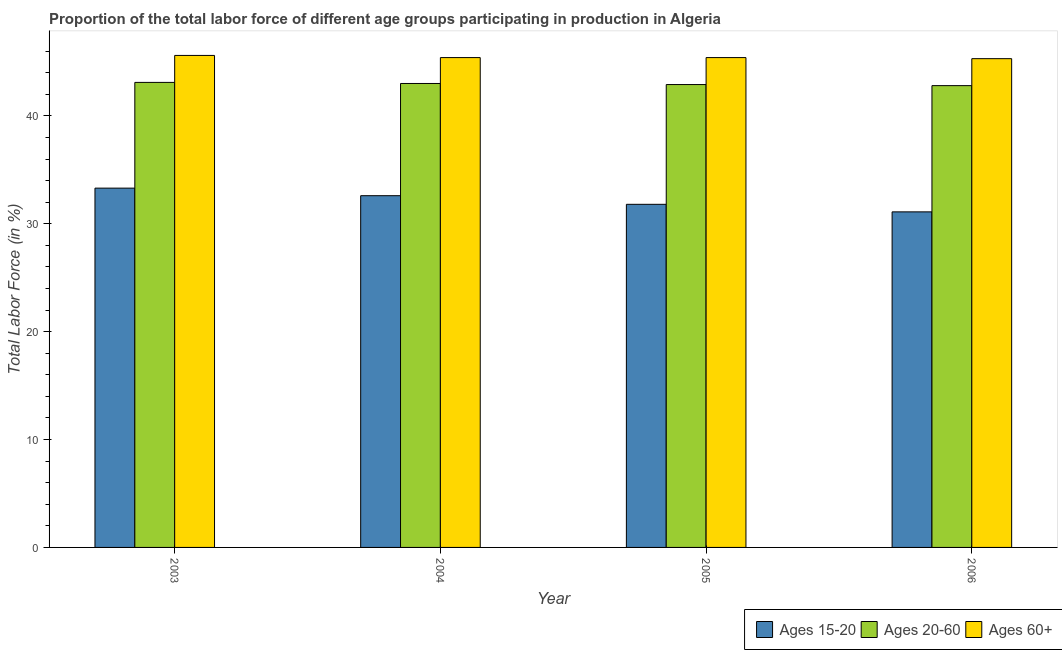How many different coloured bars are there?
Offer a terse response. 3. How many groups of bars are there?
Provide a succinct answer. 4. Are the number of bars per tick equal to the number of legend labels?
Offer a very short reply. Yes. Are the number of bars on each tick of the X-axis equal?
Your answer should be compact. Yes. How many bars are there on the 2nd tick from the left?
Your response must be concise. 3. How many bars are there on the 1st tick from the right?
Your response must be concise. 3. What is the label of the 3rd group of bars from the left?
Ensure brevity in your answer.  2005. What is the percentage of labor force within the age group 15-20 in 2004?
Give a very brief answer. 32.6. Across all years, what is the maximum percentage of labor force within the age group 15-20?
Make the answer very short. 33.3. Across all years, what is the minimum percentage of labor force above age 60?
Your answer should be compact. 45.3. In which year was the percentage of labor force above age 60 maximum?
Your response must be concise. 2003. What is the total percentage of labor force above age 60 in the graph?
Your answer should be very brief. 181.7. What is the difference between the percentage of labor force above age 60 in 2003 and that in 2004?
Your answer should be very brief. 0.2. What is the difference between the percentage of labor force within the age group 20-60 in 2005 and the percentage of labor force within the age group 15-20 in 2004?
Your response must be concise. -0.1. What is the average percentage of labor force above age 60 per year?
Your answer should be compact. 45.43. In how many years, is the percentage of labor force within the age group 15-20 greater than 28 %?
Your response must be concise. 4. What is the ratio of the percentage of labor force within the age group 20-60 in 2003 to that in 2004?
Ensure brevity in your answer.  1. Is the difference between the percentage of labor force above age 60 in 2004 and 2005 greater than the difference between the percentage of labor force within the age group 15-20 in 2004 and 2005?
Ensure brevity in your answer.  No. What is the difference between the highest and the second highest percentage of labor force within the age group 20-60?
Provide a succinct answer. 0.1. What is the difference between the highest and the lowest percentage of labor force above age 60?
Make the answer very short. 0.3. Is the sum of the percentage of labor force above age 60 in 2004 and 2005 greater than the maximum percentage of labor force within the age group 20-60 across all years?
Ensure brevity in your answer.  Yes. What does the 3rd bar from the left in 2005 represents?
Offer a terse response. Ages 60+. What does the 3rd bar from the right in 2004 represents?
Keep it short and to the point. Ages 15-20. Is it the case that in every year, the sum of the percentage of labor force within the age group 15-20 and percentage of labor force within the age group 20-60 is greater than the percentage of labor force above age 60?
Ensure brevity in your answer.  Yes. How many years are there in the graph?
Provide a short and direct response. 4. What is the difference between two consecutive major ticks on the Y-axis?
Your answer should be very brief. 10. Are the values on the major ticks of Y-axis written in scientific E-notation?
Offer a terse response. No. Does the graph contain any zero values?
Offer a terse response. No. Does the graph contain grids?
Offer a very short reply. No. Where does the legend appear in the graph?
Provide a succinct answer. Bottom right. What is the title of the graph?
Provide a succinct answer. Proportion of the total labor force of different age groups participating in production in Algeria. Does "Agricultural raw materials" appear as one of the legend labels in the graph?
Provide a succinct answer. No. What is the label or title of the X-axis?
Offer a terse response. Year. What is the label or title of the Y-axis?
Keep it short and to the point. Total Labor Force (in %). What is the Total Labor Force (in %) of Ages 15-20 in 2003?
Make the answer very short. 33.3. What is the Total Labor Force (in %) of Ages 20-60 in 2003?
Make the answer very short. 43.1. What is the Total Labor Force (in %) of Ages 60+ in 2003?
Provide a short and direct response. 45.6. What is the Total Labor Force (in %) in Ages 15-20 in 2004?
Ensure brevity in your answer.  32.6. What is the Total Labor Force (in %) in Ages 20-60 in 2004?
Offer a terse response. 43. What is the Total Labor Force (in %) of Ages 60+ in 2004?
Your answer should be very brief. 45.4. What is the Total Labor Force (in %) of Ages 15-20 in 2005?
Your answer should be very brief. 31.8. What is the Total Labor Force (in %) of Ages 20-60 in 2005?
Your response must be concise. 42.9. What is the Total Labor Force (in %) in Ages 60+ in 2005?
Your response must be concise. 45.4. What is the Total Labor Force (in %) of Ages 15-20 in 2006?
Provide a short and direct response. 31.1. What is the Total Labor Force (in %) of Ages 20-60 in 2006?
Ensure brevity in your answer.  42.8. What is the Total Labor Force (in %) in Ages 60+ in 2006?
Your answer should be very brief. 45.3. Across all years, what is the maximum Total Labor Force (in %) in Ages 15-20?
Make the answer very short. 33.3. Across all years, what is the maximum Total Labor Force (in %) of Ages 20-60?
Offer a terse response. 43.1. Across all years, what is the maximum Total Labor Force (in %) of Ages 60+?
Give a very brief answer. 45.6. Across all years, what is the minimum Total Labor Force (in %) of Ages 15-20?
Ensure brevity in your answer.  31.1. Across all years, what is the minimum Total Labor Force (in %) in Ages 20-60?
Offer a very short reply. 42.8. Across all years, what is the minimum Total Labor Force (in %) of Ages 60+?
Ensure brevity in your answer.  45.3. What is the total Total Labor Force (in %) of Ages 15-20 in the graph?
Give a very brief answer. 128.8. What is the total Total Labor Force (in %) in Ages 20-60 in the graph?
Provide a succinct answer. 171.8. What is the total Total Labor Force (in %) in Ages 60+ in the graph?
Make the answer very short. 181.7. What is the difference between the Total Labor Force (in %) in Ages 15-20 in 2003 and that in 2004?
Make the answer very short. 0.7. What is the difference between the Total Labor Force (in %) in Ages 20-60 in 2003 and that in 2004?
Your answer should be compact. 0.1. What is the difference between the Total Labor Force (in %) of Ages 60+ in 2003 and that in 2004?
Your answer should be compact. 0.2. What is the difference between the Total Labor Force (in %) in Ages 15-20 in 2003 and that in 2005?
Provide a succinct answer. 1.5. What is the difference between the Total Labor Force (in %) in Ages 60+ in 2003 and that in 2005?
Your answer should be compact. 0.2. What is the difference between the Total Labor Force (in %) of Ages 15-20 in 2003 and that in 2006?
Your response must be concise. 2.2. What is the difference between the Total Labor Force (in %) in Ages 20-60 in 2003 and that in 2006?
Your response must be concise. 0.3. What is the difference between the Total Labor Force (in %) in Ages 20-60 in 2004 and that in 2005?
Give a very brief answer. 0.1. What is the difference between the Total Labor Force (in %) in Ages 20-60 in 2004 and that in 2006?
Your response must be concise. 0.2. What is the difference between the Total Labor Force (in %) of Ages 60+ in 2004 and that in 2006?
Your answer should be compact. 0.1. What is the difference between the Total Labor Force (in %) of Ages 15-20 in 2005 and that in 2006?
Offer a terse response. 0.7. What is the difference between the Total Labor Force (in %) in Ages 60+ in 2005 and that in 2006?
Give a very brief answer. 0.1. What is the difference between the Total Labor Force (in %) in Ages 15-20 in 2003 and the Total Labor Force (in %) in Ages 20-60 in 2004?
Your answer should be compact. -9.7. What is the difference between the Total Labor Force (in %) in Ages 20-60 in 2003 and the Total Labor Force (in %) in Ages 60+ in 2004?
Make the answer very short. -2.3. What is the difference between the Total Labor Force (in %) of Ages 15-20 in 2003 and the Total Labor Force (in %) of Ages 60+ in 2005?
Give a very brief answer. -12.1. What is the difference between the Total Labor Force (in %) of Ages 20-60 in 2003 and the Total Labor Force (in %) of Ages 60+ in 2005?
Offer a terse response. -2.3. What is the difference between the Total Labor Force (in %) in Ages 15-20 in 2003 and the Total Labor Force (in %) in Ages 20-60 in 2006?
Offer a very short reply. -9.5. What is the difference between the Total Labor Force (in %) in Ages 15-20 in 2003 and the Total Labor Force (in %) in Ages 60+ in 2006?
Ensure brevity in your answer.  -12. What is the difference between the Total Labor Force (in %) of Ages 20-60 in 2003 and the Total Labor Force (in %) of Ages 60+ in 2006?
Offer a very short reply. -2.2. What is the difference between the Total Labor Force (in %) of Ages 15-20 in 2004 and the Total Labor Force (in %) of Ages 60+ in 2005?
Your answer should be compact. -12.8. What is the difference between the Total Labor Force (in %) in Ages 20-60 in 2004 and the Total Labor Force (in %) in Ages 60+ in 2005?
Ensure brevity in your answer.  -2.4. What is the difference between the Total Labor Force (in %) of Ages 15-20 in 2004 and the Total Labor Force (in %) of Ages 60+ in 2006?
Your answer should be very brief. -12.7. What is the difference between the Total Labor Force (in %) in Ages 20-60 in 2004 and the Total Labor Force (in %) in Ages 60+ in 2006?
Your response must be concise. -2.3. What is the difference between the Total Labor Force (in %) in Ages 15-20 in 2005 and the Total Labor Force (in %) in Ages 20-60 in 2006?
Provide a succinct answer. -11. What is the average Total Labor Force (in %) of Ages 15-20 per year?
Ensure brevity in your answer.  32.2. What is the average Total Labor Force (in %) in Ages 20-60 per year?
Give a very brief answer. 42.95. What is the average Total Labor Force (in %) of Ages 60+ per year?
Ensure brevity in your answer.  45.42. In the year 2003, what is the difference between the Total Labor Force (in %) in Ages 20-60 and Total Labor Force (in %) in Ages 60+?
Your answer should be very brief. -2.5. In the year 2005, what is the difference between the Total Labor Force (in %) of Ages 20-60 and Total Labor Force (in %) of Ages 60+?
Provide a succinct answer. -2.5. In the year 2006, what is the difference between the Total Labor Force (in %) in Ages 15-20 and Total Labor Force (in %) in Ages 60+?
Give a very brief answer. -14.2. What is the ratio of the Total Labor Force (in %) in Ages 15-20 in 2003 to that in 2004?
Give a very brief answer. 1.02. What is the ratio of the Total Labor Force (in %) in Ages 20-60 in 2003 to that in 2004?
Provide a short and direct response. 1. What is the ratio of the Total Labor Force (in %) of Ages 15-20 in 2003 to that in 2005?
Ensure brevity in your answer.  1.05. What is the ratio of the Total Labor Force (in %) in Ages 60+ in 2003 to that in 2005?
Ensure brevity in your answer.  1. What is the ratio of the Total Labor Force (in %) of Ages 15-20 in 2003 to that in 2006?
Your response must be concise. 1.07. What is the ratio of the Total Labor Force (in %) of Ages 60+ in 2003 to that in 2006?
Offer a very short reply. 1.01. What is the ratio of the Total Labor Force (in %) of Ages 15-20 in 2004 to that in 2005?
Your response must be concise. 1.03. What is the ratio of the Total Labor Force (in %) of Ages 20-60 in 2004 to that in 2005?
Make the answer very short. 1. What is the ratio of the Total Labor Force (in %) in Ages 60+ in 2004 to that in 2005?
Your answer should be compact. 1. What is the ratio of the Total Labor Force (in %) in Ages 15-20 in 2004 to that in 2006?
Give a very brief answer. 1.05. What is the ratio of the Total Labor Force (in %) of Ages 15-20 in 2005 to that in 2006?
Your answer should be compact. 1.02. What is the ratio of the Total Labor Force (in %) of Ages 20-60 in 2005 to that in 2006?
Ensure brevity in your answer.  1. What is the ratio of the Total Labor Force (in %) of Ages 60+ in 2005 to that in 2006?
Offer a very short reply. 1. What is the difference between the highest and the second highest Total Labor Force (in %) in Ages 15-20?
Make the answer very short. 0.7. What is the difference between the highest and the lowest Total Labor Force (in %) in Ages 60+?
Your response must be concise. 0.3. 